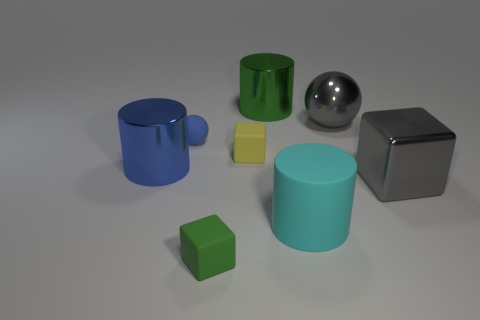Add 2 big rubber cylinders. How many objects exist? 10 Subtract all rubber blocks. How many blocks are left? 1 Subtract all yellow blocks. How many blocks are left? 2 Subtract all cylinders. How many objects are left? 5 Subtract all large blue cylinders. Subtract all small matte spheres. How many objects are left? 6 Add 5 shiny blocks. How many shiny blocks are left? 6 Add 7 blue cylinders. How many blue cylinders exist? 8 Subtract 1 yellow cubes. How many objects are left? 7 Subtract 3 cubes. How many cubes are left? 0 Subtract all green cubes. Subtract all green spheres. How many cubes are left? 2 